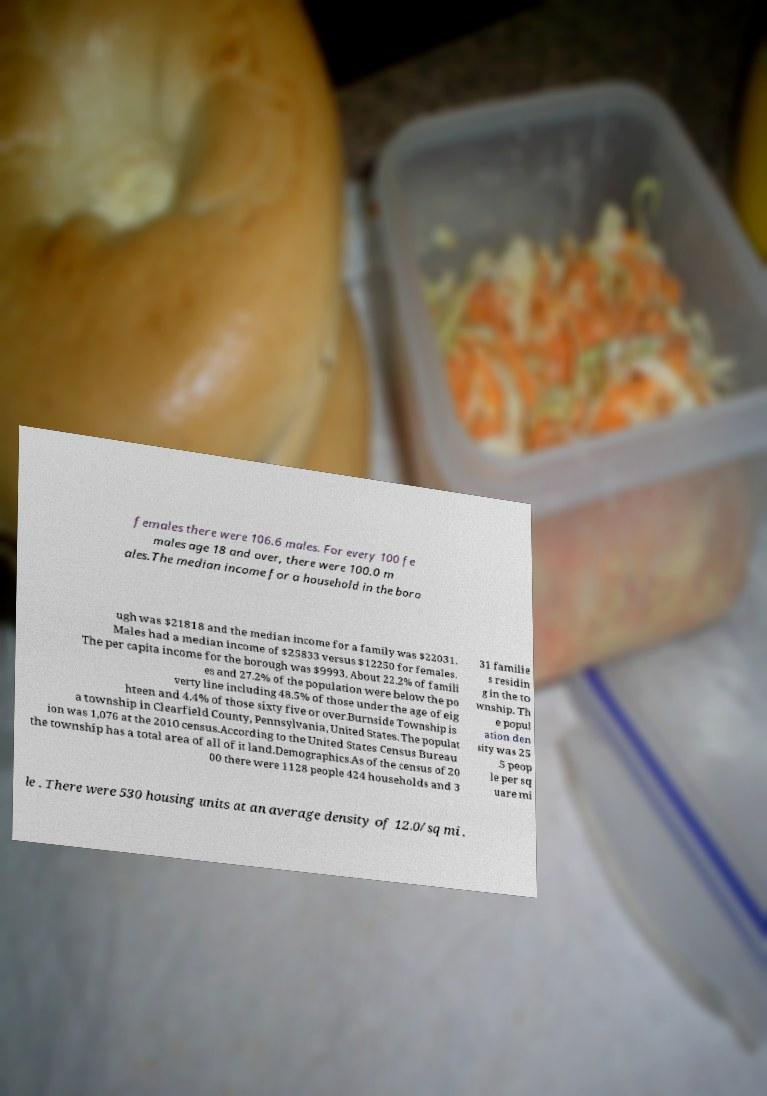Please read and relay the text visible in this image. What does it say? females there were 106.6 males. For every 100 fe males age 18 and over, there were 100.0 m ales.The median income for a household in the boro ugh was $21818 and the median income for a family was $22031. Males had a median income of $25833 versus $12250 for females. The per capita income for the borough was $9993. About 22.2% of famili es and 27.2% of the population were below the po verty line including 48.5% of those under the age of eig hteen and 4.4% of those sixty five or over.Burnside Township is a township in Clearfield County, Pennsylvania, United States. The populat ion was 1,076 at the 2010 census.According to the United States Census Bureau the township has a total area of all of it land.Demographics.As of the census of 20 00 there were 1128 people 424 households and 3 31 familie s residin g in the to wnship. Th e popul ation den sity was 25 .5 peop le per sq uare mi le . There were 530 housing units at an average density of 12.0/sq mi . 